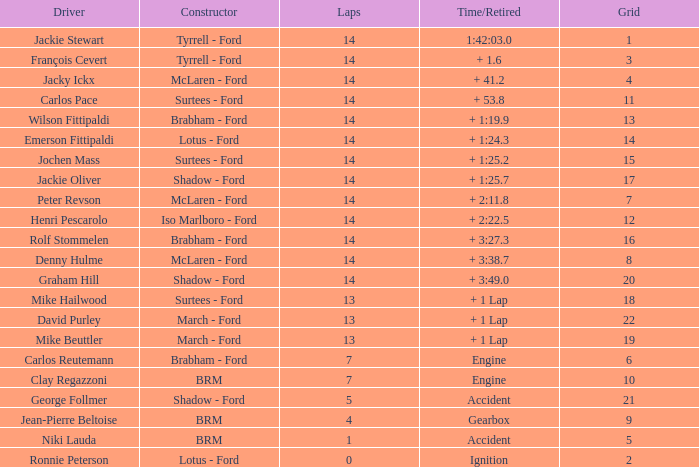3? None. 